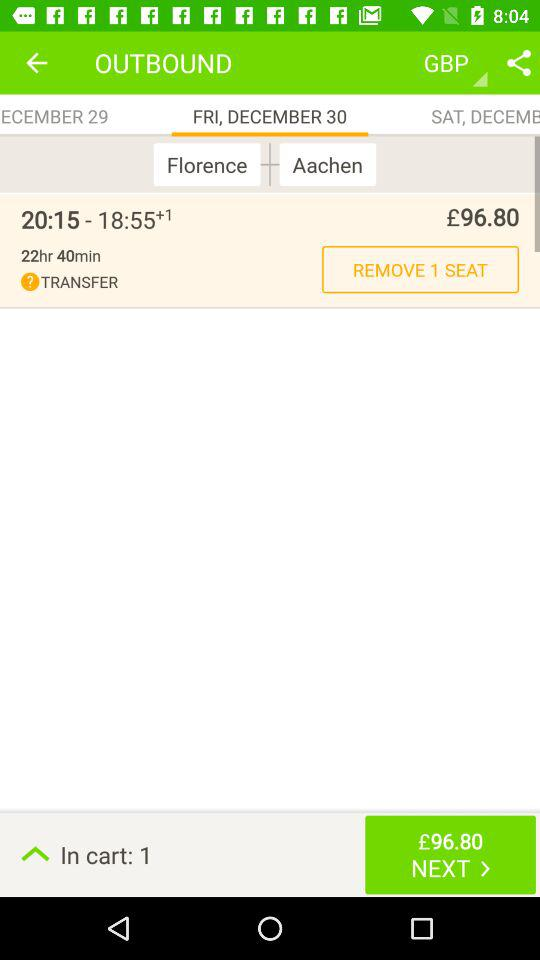How many seats are in the cart?
Answer the question using a single word or phrase. 1 